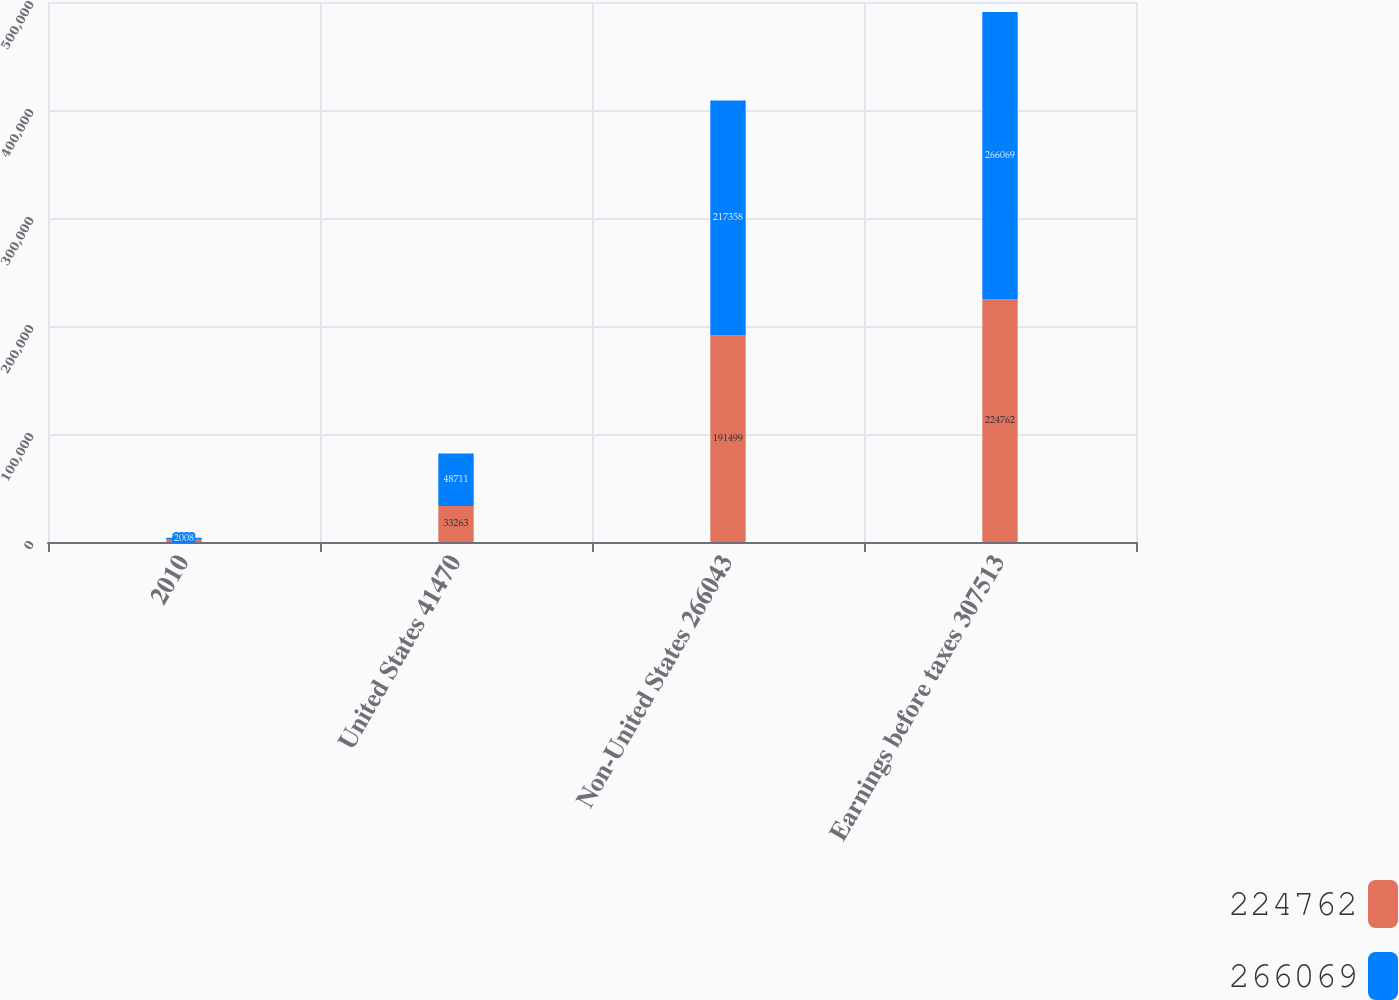<chart> <loc_0><loc_0><loc_500><loc_500><stacked_bar_chart><ecel><fcel>2010<fcel>United States 41470<fcel>Non-United States 266043<fcel>Earnings before taxes 307513<nl><fcel>224762<fcel>2009<fcel>33263<fcel>191499<fcel>224762<nl><fcel>266069<fcel>2008<fcel>48711<fcel>217358<fcel>266069<nl></chart> 